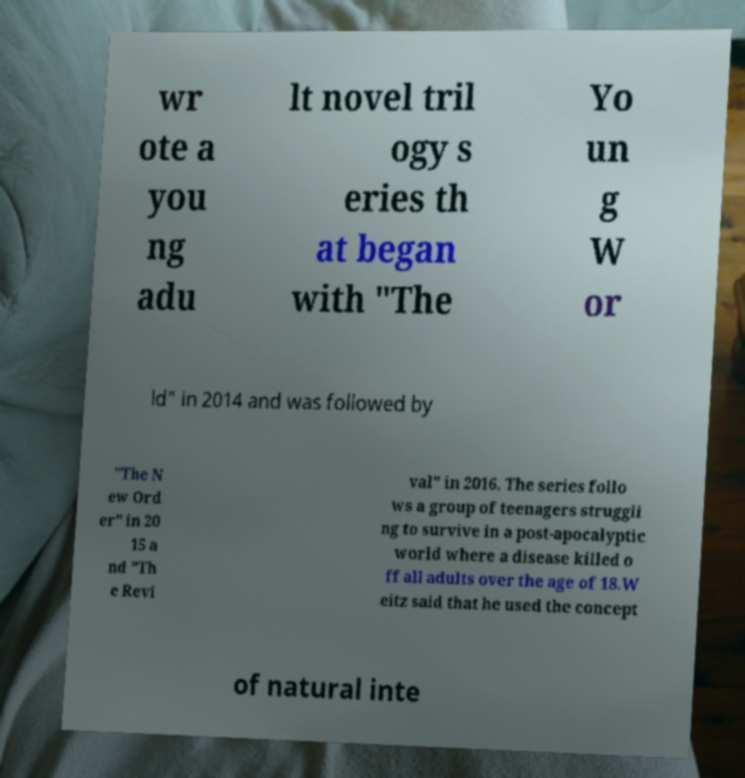Can you accurately transcribe the text from the provided image for me? wr ote a you ng adu lt novel tril ogy s eries th at began with "The Yo un g W or ld" in 2014 and was followed by "The N ew Ord er" in 20 15 a nd "Th e Revi val" in 2016. The series follo ws a group of teenagers struggli ng to survive in a post-apocalyptic world where a disease killed o ff all adults over the age of 18.W eitz said that he used the concept of natural inte 